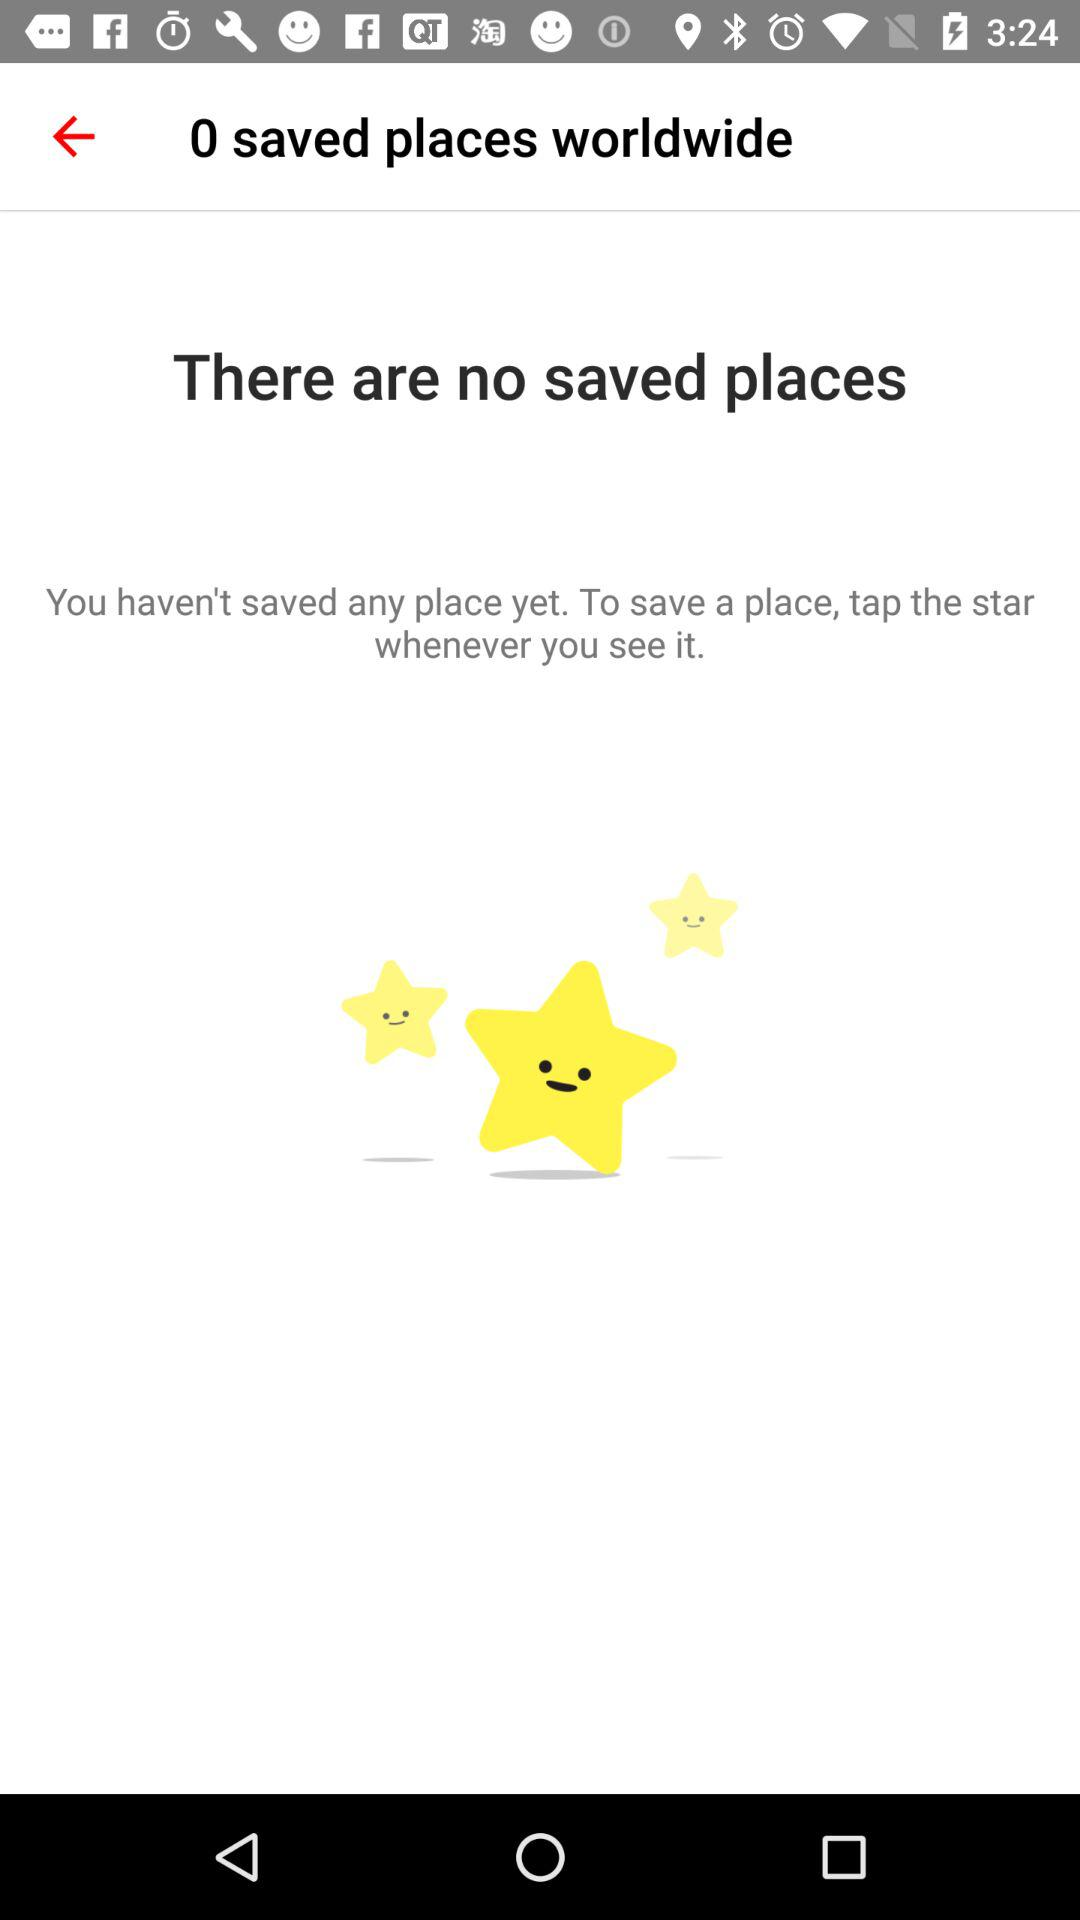How many saved places are there in total? There are 0 saved places in total. 